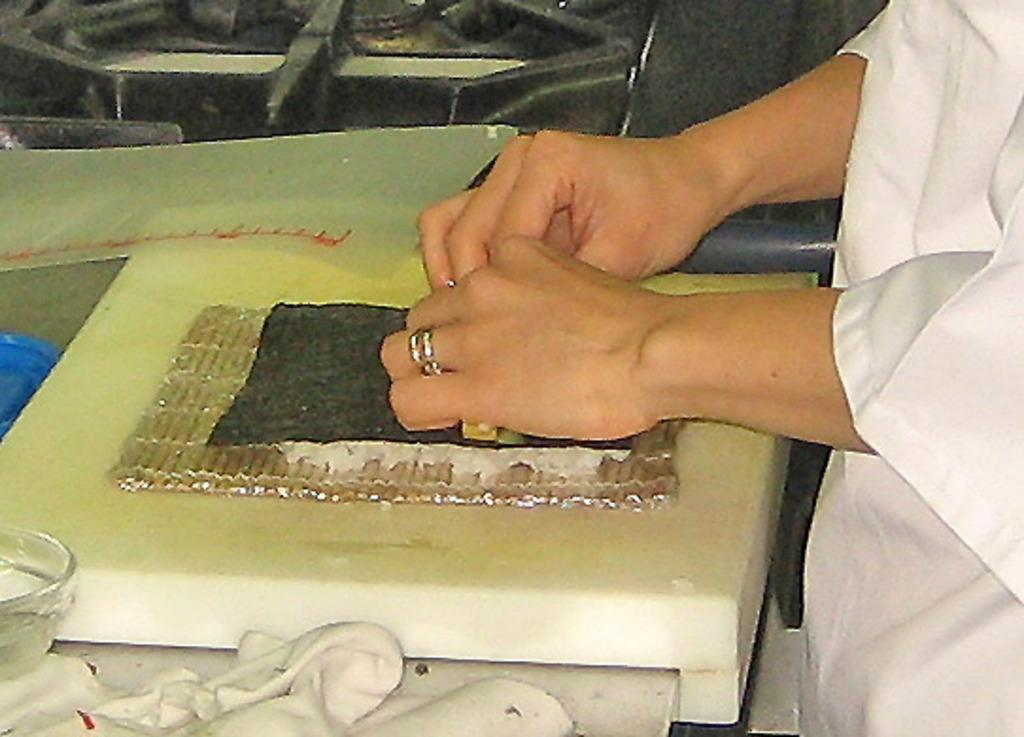What is the main subject of the image? There is a person standing in the image. Can you describe the person's clothing? The person is wearing white clothes. What other object can be seen in the image? There is a glass bowl in the image. Are there any other objects present in the image? Yes, there are other objects present in the image. What type of treatment is being administered to the trees in the image? There are no trees present in the image, so no treatment is being administered to them. Can you tell me how many members are on the committee in the image? There is no committee present in the image. 